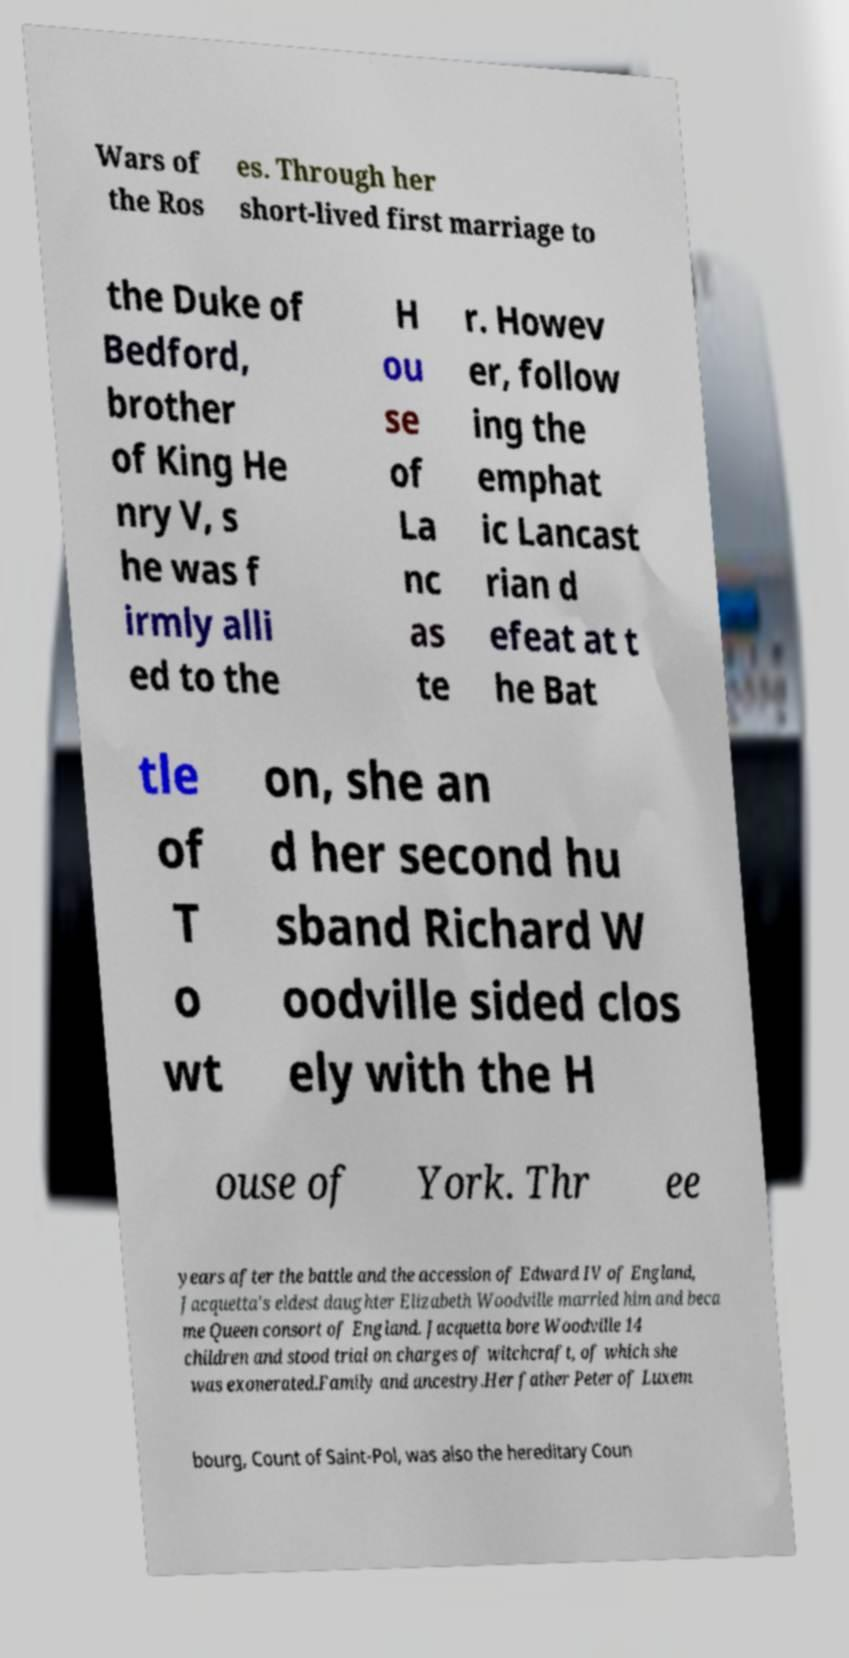Please read and relay the text visible in this image. What does it say? Wars of the Ros es. Through her short-lived first marriage to the Duke of Bedford, brother of King He nry V, s he was f irmly alli ed to the H ou se of La nc as te r. Howev er, follow ing the emphat ic Lancast rian d efeat at t he Bat tle of T o wt on, she an d her second hu sband Richard W oodville sided clos ely with the H ouse of York. Thr ee years after the battle and the accession of Edward IV of England, Jacquetta's eldest daughter Elizabeth Woodville married him and beca me Queen consort of England. Jacquetta bore Woodville 14 children and stood trial on charges of witchcraft, of which she was exonerated.Family and ancestry.Her father Peter of Luxem bourg, Count of Saint-Pol, was also the hereditary Coun 